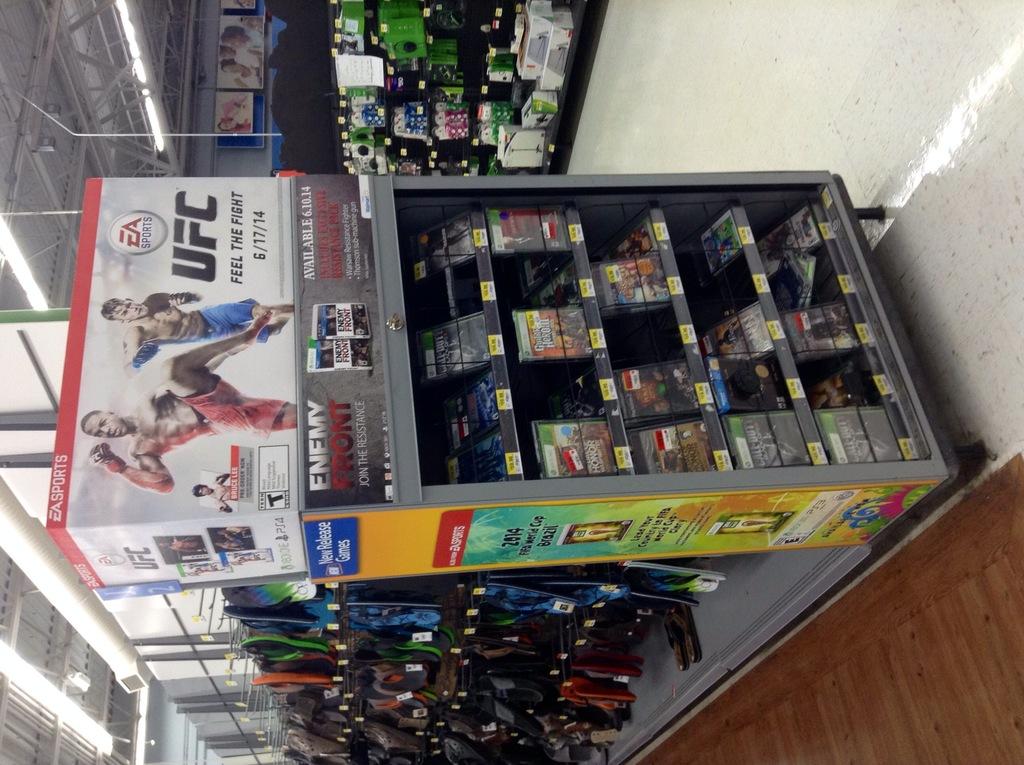What is the name of the ea game featured?
Provide a short and direct response. Ufc. What is the date on the sign?
Keep it short and to the point. 6/17/14. 